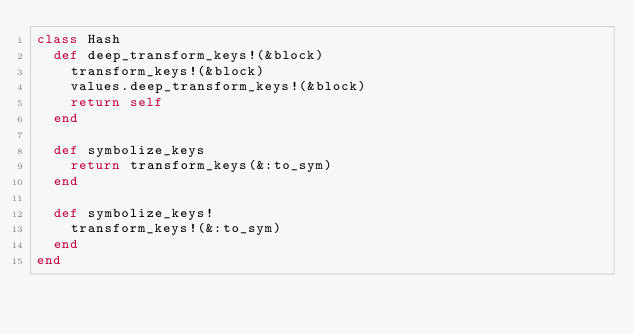<code> <loc_0><loc_0><loc_500><loc_500><_Ruby_>class Hash
  def deep_transform_keys!(&block)
    transform_keys!(&block)
    values.deep_transform_keys!(&block)
    return self
  end

  def symbolize_keys
    return transform_keys(&:to_sym)
  end

  def symbolize_keys!
    transform_keys!(&:to_sym)
  end
end
</code> 